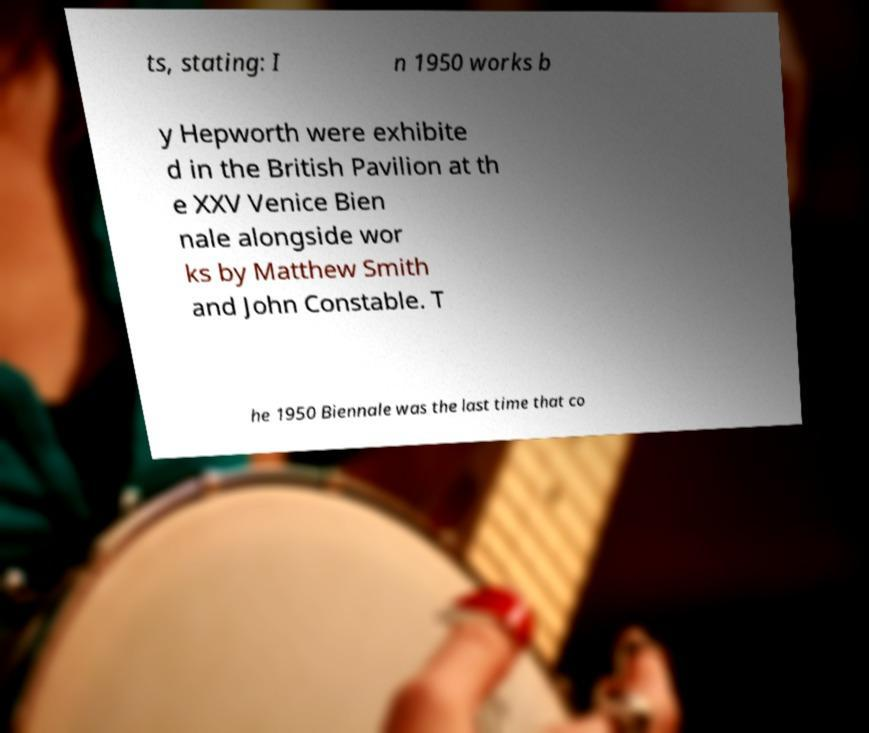Can you accurately transcribe the text from the provided image for me? ts, stating: I n 1950 works b y Hepworth were exhibite d in the British Pavilion at th e XXV Venice Bien nale alongside wor ks by Matthew Smith and John Constable. T he 1950 Biennale was the last time that co 